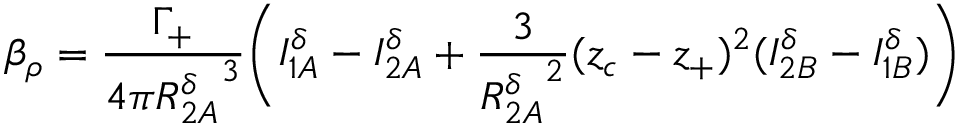<formula> <loc_0><loc_0><loc_500><loc_500>\beta _ { \rho } = \frac { \Gamma _ { + } } { 4 \pi { R _ { 2 A } ^ { \delta } } ^ { 3 } } \left ( I _ { 1 A } ^ { \delta } - I _ { 2 A } ^ { \delta } + \frac { 3 } { { R _ { 2 A } ^ { \delta } } ^ { 2 } } ( z _ { c } - z _ { + } ) ^ { 2 } ( I _ { 2 B } ^ { \delta } - I _ { 1 B } ^ { \delta } ) \right )</formula> 